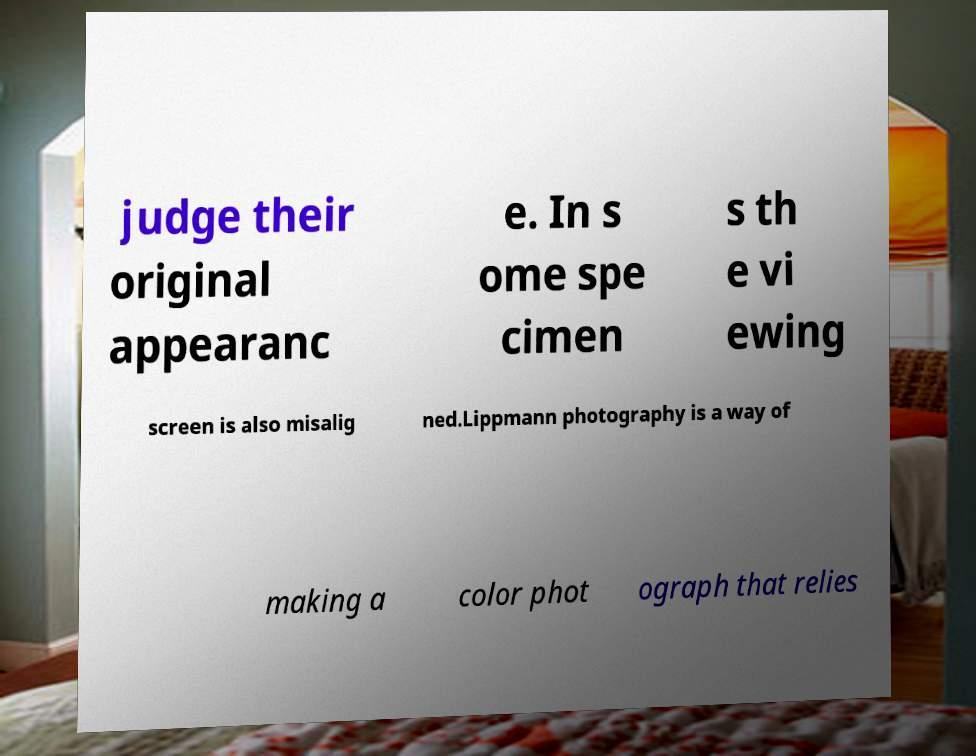Could you assist in decoding the text presented in this image and type it out clearly? judge their original appearanc e. In s ome spe cimen s th e vi ewing screen is also misalig ned.Lippmann photography is a way of making a color phot ograph that relies 